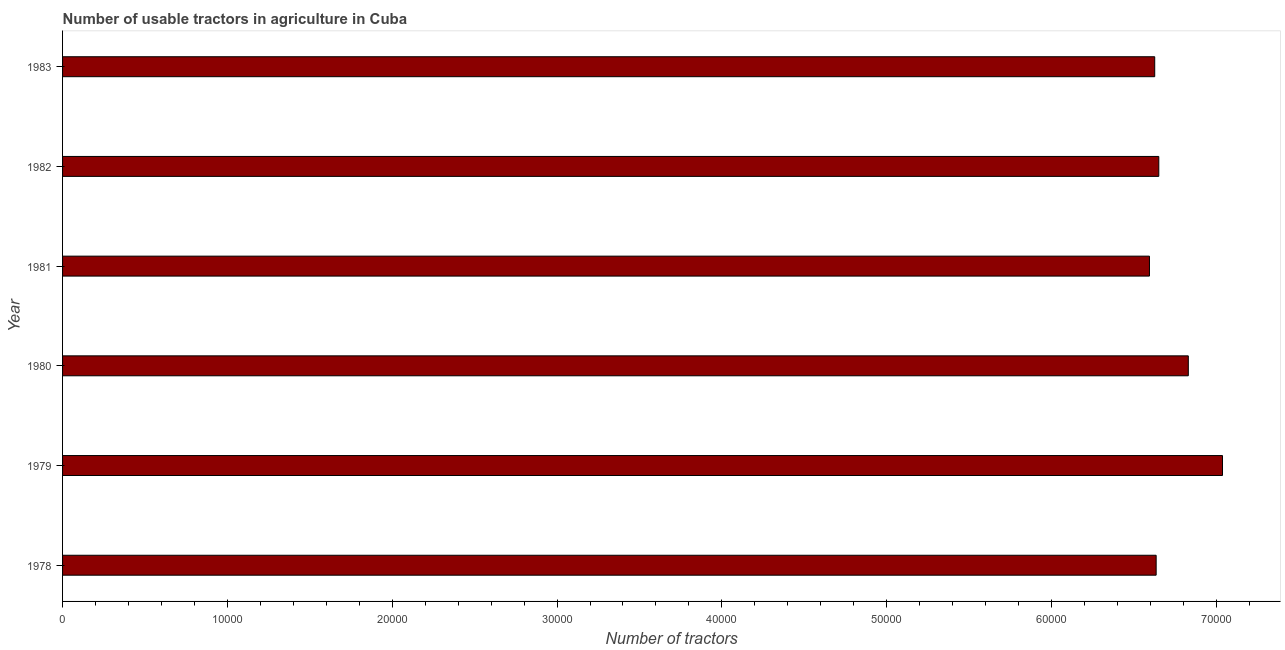What is the title of the graph?
Keep it short and to the point. Number of usable tractors in agriculture in Cuba. What is the label or title of the X-axis?
Your answer should be very brief. Number of tractors. What is the label or title of the Y-axis?
Ensure brevity in your answer.  Year. What is the number of tractors in 1982?
Provide a short and direct response. 6.65e+04. Across all years, what is the maximum number of tractors?
Provide a succinct answer. 7.04e+04. Across all years, what is the minimum number of tractors?
Your response must be concise. 6.59e+04. In which year was the number of tractors maximum?
Offer a terse response. 1979. In which year was the number of tractors minimum?
Ensure brevity in your answer.  1981. What is the sum of the number of tractors?
Keep it short and to the point. 4.04e+05. What is the difference between the number of tractors in 1981 and 1983?
Give a very brief answer. -319. What is the average number of tractors per year?
Ensure brevity in your answer.  6.73e+04. What is the median number of tractors?
Provide a succinct answer. 6.64e+04. Do a majority of the years between 1980 and 1981 (inclusive) have number of tractors greater than 24000 ?
Offer a terse response. Yes. Is the difference between the number of tractors in 1979 and 1983 greater than the difference between any two years?
Keep it short and to the point. No. What is the difference between the highest and the second highest number of tractors?
Give a very brief answer. 2074. Is the sum of the number of tractors in 1978 and 1981 greater than the maximum number of tractors across all years?
Offer a very short reply. Yes. What is the difference between the highest and the lowest number of tractors?
Your answer should be compact. 4431. In how many years, is the number of tractors greater than the average number of tractors taken over all years?
Your response must be concise. 2. Are all the bars in the graph horizontal?
Provide a succinct answer. Yes. How many years are there in the graph?
Your response must be concise. 6. What is the Number of tractors of 1978?
Make the answer very short. 6.63e+04. What is the Number of tractors of 1979?
Provide a succinct answer. 7.04e+04. What is the Number of tractors of 1980?
Keep it short and to the point. 6.83e+04. What is the Number of tractors of 1981?
Provide a short and direct response. 6.59e+04. What is the Number of tractors of 1982?
Provide a short and direct response. 6.65e+04. What is the Number of tractors in 1983?
Give a very brief answer. 6.63e+04. What is the difference between the Number of tractors in 1978 and 1979?
Offer a very short reply. -4025. What is the difference between the Number of tractors in 1978 and 1980?
Offer a very short reply. -1951. What is the difference between the Number of tractors in 1978 and 1981?
Your answer should be very brief. 406. What is the difference between the Number of tractors in 1978 and 1982?
Your answer should be very brief. -160. What is the difference between the Number of tractors in 1979 and 1980?
Provide a succinct answer. 2074. What is the difference between the Number of tractors in 1979 and 1981?
Offer a very short reply. 4431. What is the difference between the Number of tractors in 1979 and 1982?
Ensure brevity in your answer.  3865. What is the difference between the Number of tractors in 1979 and 1983?
Your response must be concise. 4112. What is the difference between the Number of tractors in 1980 and 1981?
Offer a terse response. 2357. What is the difference between the Number of tractors in 1980 and 1982?
Provide a succinct answer. 1791. What is the difference between the Number of tractors in 1980 and 1983?
Your answer should be compact. 2038. What is the difference between the Number of tractors in 1981 and 1982?
Provide a succinct answer. -566. What is the difference between the Number of tractors in 1981 and 1983?
Offer a very short reply. -319. What is the difference between the Number of tractors in 1982 and 1983?
Keep it short and to the point. 247. What is the ratio of the Number of tractors in 1978 to that in 1979?
Your answer should be compact. 0.94. What is the ratio of the Number of tractors in 1978 to that in 1982?
Give a very brief answer. 1. What is the ratio of the Number of tractors in 1979 to that in 1980?
Offer a very short reply. 1.03. What is the ratio of the Number of tractors in 1979 to that in 1981?
Ensure brevity in your answer.  1.07. What is the ratio of the Number of tractors in 1979 to that in 1982?
Your answer should be very brief. 1.06. What is the ratio of the Number of tractors in 1979 to that in 1983?
Keep it short and to the point. 1.06. What is the ratio of the Number of tractors in 1980 to that in 1981?
Offer a very short reply. 1.04. What is the ratio of the Number of tractors in 1980 to that in 1983?
Provide a succinct answer. 1.03. What is the ratio of the Number of tractors in 1981 to that in 1982?
Offer a very short reply. 0.99. 